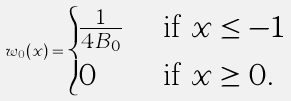<formula> <loc_0><loc_0><loc_500><loc_500>w _ { 0 } ( x ) = \begin{cases} \frac { 1 } { 4 B _ { 0 } } & \text { if } x \leq - 1 \\ 0 & \text { if } x \geq 0 . \end{cases}</formula> 